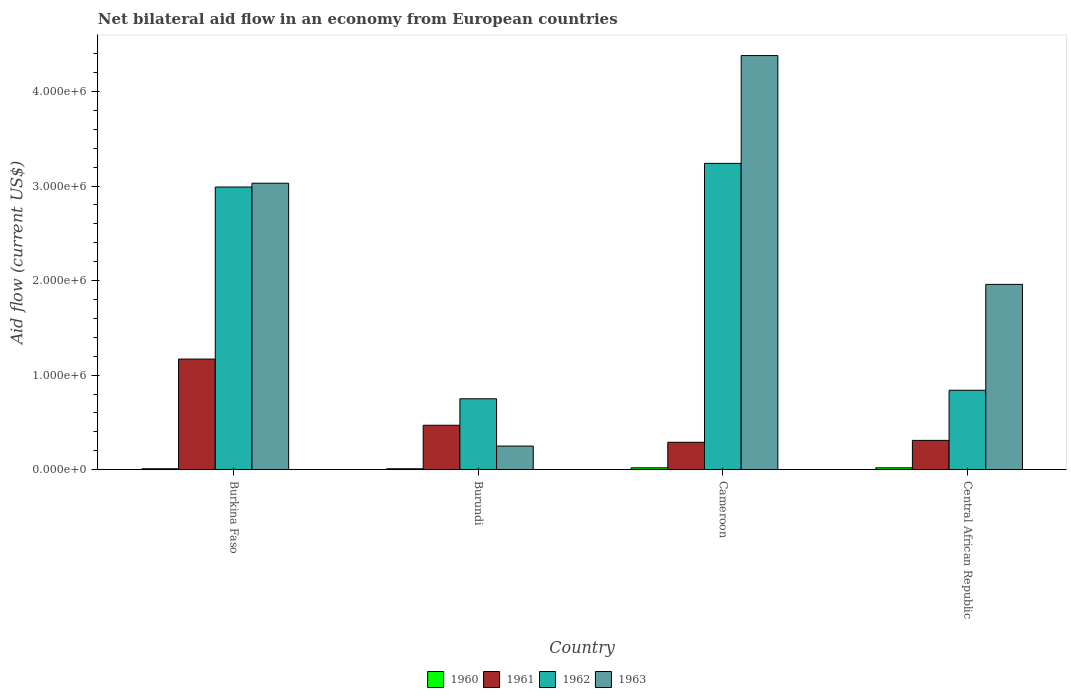How many groups of bars are there?
Give a very brief answer. 4. Are the number of bars per tick equal to the number of legend labels?
Make the answer very short. Yes. How many bars are there on the 4th tick from the left?
Provide a short and direct response. 4. How many bars are there on the 2nd tick from the right?
Provide a succinct answer. 4. What is the label of the 4th group of bars from the left?
Your response must be concise. Central African Republic. What is the net bilateral aid flow in 1962 in Central African Republic?
Offer a very short reply. 8.40e+05. Across all countries, what is the maximum net bilateral aid flow in 1963?
Offer a terse response. 4.38e+06. In which country was the net bilateral aid flow in 1960 maximum?
Offer a terse response. Cameroon. In which country was the net bilateral aid flow in 1960 minimum?
Provide a succinct answer. Burkina Faso. What is the total net bilateral aid flow in 1962 in the graph?
Provide a short and direct response. 7.82e+06. What is the difference between the net bilateral aid flow in 1963 in Burkina Faso and that in Central African Republic?
Make the answer very short. 1.07e+06. What is the difference between the net bilateral aid flow in 1961 in Central African Republic and the net bilateral aid flow in 1962 in Burkina Faso?
Your answer should be compact. -2.68e+06. What is the average net bilateral aid flow in 1961 per country?
Your answer should be very brief. 5.60e+05. What is the difference between the net bilateral aid flow of/in 1963 and net bilateral aid flow of/in 1962 in Central African Republic?
Provide a succinct answer. 1.12e+06. What is the ratio of the net bilateral aid flow in 1962 in Burkina Faso to that in Central African Republic?
Make the answer very short. 3.56. Is the net bilateral aid flow in 1960 in Cameroon less than that in Central African Republic?
Give a very brief answer. No. What is the difference between the highest and the lowest net bilateral aid flow in 1961?
Keep it short and to the point. 8.80e+05. Is it the case that in every country, the sum of the net bilateral aid flow in 1960 and net bilateral aid flow in 1963 is greater than the sum of net bilateral aid flow in 1962 and net bilateral aid flow in 1961?
Your answer should be compact. No. How many bars are there?
Give a very brief answer. 16. Are all the bars in the graph horizontal?
Keep it short and to the point. No. What is the difference between two consecutive major ticks on the Y-axis?
Keep it short and to the point. 1.00e+06. Are the values on the major ticks of Y-axis written in scientific E-notation?
Your answer should be compact. Yes. What is the title of the graph?
Give a very brief answer. Net bilateral aid flow in an economy from European countries. Does "1965" appear as one of the legend labels in the graph?
Offer a very short reply. No. What is the label or title of the X-axis?
Keep it short and to the point. Country. What is the label or title of the Y-axis?
Offer a very short reply. Aid flow (current US$). What is the Aid flow (current US$) of 1960 in Burkina Faso?
Offer a terse response. 10000. What is the Aid flow (current US$) of 1961 in Burkina Faso?
Offer a very short reply. 1.17e+06. What is the Aid flow (current US$) in 1962 in Burkina Faso?
Offer a very short reply. 2.99e+06. What is the Aid flow (current US$) in 1963 in Burkina Faso?
Your answer should be very brief. 3.03e+06. What is the Aid flow (current US$) in 1962 in Burundi?
Your answer should be very brief. 7.50e+05. What is the Aid flow (current US$) in 1960 in Cameroon?
Keep it short and to the point. 2.00e+04. What is the Aid flow (current US$) of 1961 in Cameroon?
Give a very brief answer. 2.90e+05. What is the Aid flow (current US$) in 1962 in Cameroon?
Your answer should be compact. 3.24e+06. What is the Aid flow (current US$) of 1963 in Cameroon?
Ensure brevity in your answer.  4.38e+06. What is the Aid flow (current US$) in 1961 in Central African Republic?
Ensure brevity in your answer.  3.10e+05. What is the Aid flow (current US$) of 1962 in Central African Republic?
Your answer should be very brief. 8.40e+05. What is the Aid flow (current US$) in 1963 in Central African Republic?
Give a very brief answer. 1.96e+06. Across all countries, what is the maximum Aid flow (current US$) in 1960?
Offer a terse response. 2.00e+04. Across all countries, what is the maximum Aid flow (current US$) in 1961?
Make the answer very short. 1.17e+06. Across all countries, what is the maximum Aid flow (current US$) in 1962?
Offer a terse response. 3.24e+06. Across all countries, what is the maximum Aid flow (current US$) in 1963?
Offer a terse response. 4.38e+06. Across all countries, what is the minimum Aid flow (current US$) of 1960?
Your answer should be compact. 10000. Across all countries, what is the minimum Aid flow (current US$) of 1962?
Provide a succinct answer. 7.50e+05. Across all countries, what is the minimum Aid flow (current US$) of 1963?
Your answer should be very brief. 2.50e+05. What is the total Aid flow (current US$) in 1960 in the graph?
Ensure brevity in your answer.  6.00e+04. What is the total Aid flow (current US$) of 1961 in the graph?
Make the answer very short. 2.24e+06. What is the total Aid flow (current US$) of 1962 in the graph?
Ensure brevity in your answer.  7.82e+06. What is the total Aid flow (current US$) of 1963 in the graph?
Your answer should be compact. 9.62e+06. What is the difference between the Aid flow (current US$) of 1960 in Burkina Faso and that in Burundi?
Your response must be concise. 0. What is the difference between the Aid flow (current US$) of 1962 in Burkina Faso and that in Burundi?
Offer a terse response. 2.24e+06. What is the difference between the Aid flow (current US$) of 1963 in Burkina Faso and that in Burundi?
Your response must be concise. 2.78e+06. What is the difference between the Aid flow (current US$) in 1961 in Burkina Faso and that in Cameroon?
Make the answer very short. 8.80e+05. What is the difference between the Aid flow (current US$) of 1962 in Burkina Faso and that in Cameroon?
Make the answer very short. -2.50e+05. What is the difference between the Aid flow (current US$) in 1963 in Burkina Faso and that in Cameroon?
Make the answer very short. -1.35e+06. What is the difference between the Aid flow (current US$) in 1960 in Burkina Faso and that in Central African Republic?
Ensure brevity in your answer.  -10000. What is the difference between the Aid flow (current US$) of 1961 in Burkina Faso and that in Central African Republic?
Your response must be concise. 8.60e+05. What is the difference between the Aid flow (current US$) of 1962 in Burkina Faso and that in Central African Republic?
Offer a very short reply. 2.15e+06. What is the difference between the Aid flow (current US$) in 1963 in Burkina Faso and that in Central African Republic?
Give a very brief answer. 1.07e+06. What is the difference between the Aid flow (current US$) in 1960 in Burundi and that in Cameroon?
Your answer should be very brief. -10000. What is the difference between the Aid flow (current US$) of 1961 in Burundi and that in Cameroon?
Offer a terse response. 1.80e+05. What is the difference between the Aid flow (current US$) in 1962 in Burundi and that in Cameroon?
Your answer should be very brief. -2.49e+06. What is the difference between the Aid flow (current US$) in 1963 in Burundi and that in Cameroon?
Keep it short and to the point. -4.13e+06. What is the difference between the Aid flow (current US$) of 1960 in Burundi and that in Central African Republic?
Your answer should be very brief. -10000. What is the difference between the Aid flow (current US$) of 1962 in Burundi and that in Central African Republic?
Keep it short and to the point. -9.00e+04. What is the difference between the Aid flow (current US$) in 1963 in Burundi and that in Central African Republic?
Make the answer very short. -1.71e+06. What is the difference between the Aid flow (current US$) of 1960 in Cameroon and that in Central African Republic?
Offer a very short reply. 0. What is the difference between the Aid flow (current US$) in 1962 in Cameroon and that in Central African Republic?
Give a very brief answer. 2.40e+06. What is the difference between the Aid flow (current US$) of 1963 in Cameroon and that in Central African Republic?
Offer a terse response. 2.42e+06. What is the difference between the Aid flow (current US$) in 1960 in Burkina Faso and the Aid flow (current US$) in 1961 in Burundi?
Provide a succinct answer. -4.60e+05. What is the difference between the Aid flow (current US$) in 1960 in Burkina Faso and the Aid flow (current US$) in 1962 in Burundi?
Provide a succinct answer. -7.40e+05. What is the difference between the Aid flow (current US$) in 1960 in Burkina Faso and the Aid flow (current US$) in 1963 in Burundi?
Provide a short and direct response. -2.40e+05. What is the difference between the Aid flow (current US$) of 1961 in Burkina Faso and the Aid flow (current US$) of 1963 in Burundi?
Give a very brief answer. 9.20e+05. What is the difference between the Aid flow (current US$) in 1962 in Burkina Faso and the Aid flow (current US$) in 1963 in Burundi?
Make the answer very short. 2.74e+06. What is the difference between the Aid flow (current US$) of 1960 in Burkina Faso and the Aid flow (current US$) of 1961 in Cameroon?
Make the answer very short. -2.80e+05. What is the difference between the Aid flow (current US$) in 1960 in Burkina Faso and the Aid flow (current US$) in 1962 in Cameroon?
Your response must be concise. -3.23e+06. What is the difference between the Aid flow (current US$) of 1960 in Burkina Faso and the Aid flow (current US$) of 1963 in Cameroon?
Provide a short and direct response. -4.37e+06. What is the difference between the Aid flow (current US$) of 1961 in Burkina Faso and the Aid flow (current US$) of 1962 in Cameroon?
Offer a very short reply. -2.07e+06. What is the difference between the Aid flow (current US$) in 1961 in Burkina Faso and the Aid flow (current US$) in 1963 in Cameroon?
Offer a very short reply. -3.21e+06. What is the difference between the Aid flow (current US$) in 1962 in Burkina Faso and the Aid flow (current US$) in 1963 in Cameroon?
Offer a very short reply. -1.39e+06. What is the difference between the Aid flow (current US$) of 1960 in Burkina Faso and the Aid flow (current US$) of 1962 in Central African Republic?
Offer a very short reply. -8.30e+05. What is the difference between the Aid flow (current US$) of 1960 in Burkina Faso and the Aid flow (current US$) of 1963 in Central African Republic?
Provide a succinct answer. -1.95e+06. What is the difference between the Aid flow (current US$) in 1961 in Burkina Faso and the Aid flow (current US$) in 1962 in Central African Republic?
Offer a very short reply. 3.30e+05. What is the difference between the Aid flow (current US$) in 1961 in Burkina Faso and the Aid flow (current US$) in 1963 in Central African Republic?
Offer a terse response. -7.90e+05. What is the difference between the Aid flow (current US$) of 1962 in Burkina Faso and the Aid flow (current US$) of 1963 in Central African Republic?
Your answer should be compact. 1.03e+06. What is the difference between the Aid flow (current US$) of 1960 in Burundi and the Aid flow (current US$) of 1961 in Cameroon?
Provide a succinct answer. -2.80e+05. What is the difference between the Aid flow (current US$) in 1960 in Burundi and the Aid flow (current US$) in 1962 in Cameroon?
Keep it short and to the point. -3.23e+06. What is the difference between the Aid flow (current US$) in 1960 in Burundi and the Aid flow (current US$) in 1963 in Cameroon?
Provide a succinct answer. -4.37e+06. What is the difference between the Aid flow (current US$) in 1961 in Burundi and the Aid flow (current US$) in 1962 in Cameroon?
Your answer should be compact. -2.77e+06. What is the difference between the Aid flow (current US$) in 1961 in Burundi and the Aid flow (current US$) in 1963 in Cameroon?
Offer a very short reply. -3.91e+06. What is the difference between the Aid flow (current US$) in 1962 in Burundi and the Aid flow (current US$) in 1963 in Cameroon?
Make the answer very short. -3.63e+06. What is the difference between the Aid flow (current US$) of 1960 in Burundi and the Aid flow (current US$) of 1962 in Central African Republic?
Offer a very short reply. -8.30e+05. What is the difference between the Aid flow (current US$) of 1960 in Burundi and the Aid flow (current US$) of 1963 in Central African Republic?
Provide a short and direct response. -1.95e+06. What is the difference between the Aid flow (current US$) in 1961 in Burundi and the Aid flow (current US$) in 1962 in Central African Republic?
Keep it short and to the point. -3.70e+05. What is the difference between the Aid flow (current US$) of 1961 in Burundi and the Aid flow (current US$) of 1963 in Central African Republic?
Offer a very short reply. -1.49e+06. What is the difference between the Aid flow (current US$) of 1962 in Burundi and the Aid flow (current US$) of 1963 in Central African Republic?
Make the answer very short. -1.21e+06. What is the difference between the Aid flow (current US$) in 1960 in Cameroon and the Aid flow (current US$) in 1961 in Central African Republic?
Your answer should be very brief. -2.90e+05. What is the difference between the Aid flow (current US$) of 1960 in Cameroon and the Aid flow (current US$) of 1962 in Central African Republic?
Keep it short and to the point. -8.20e+05. What is the difference between the Aid flow (current US$) of 1960 in Cameroon and the Aid flow (current US$) of 1963 in Central African Republic?
Give a very brief answer. -1.94e+06. What is the difference between the Aid flow (current US$) of 1961 in Cameroon and the Aid flow (current US$) of 1962 in Central African Republic?
Make the answer very short. -5.50e+05. What is the difference between the Aid flow (current US$) of 1961 in Cameroon and the Aid flow (current US$) of 1963 in Central African Republic?
Offer a terse response. -1.67e+06. What is the difference between the Aid flow (current US$) in 1962 in Cameroon and the Aid flow (current US$) in 1963 in Central African Republic?
Provide a short and direct response. 1.28e+06. What is the average Aid flow (current US$) in 1960 per country?
Provide a succinct answer. 1.50e+04. What is the average Aid flow (current US$) of 1961 per country?
Provide a short and direct response. 5.60e+05. What is the average Aid flow (current US$) in 1962 per country?
Offer a terse response. 1.96e+06. What is the average Aid flow (current US$) in 1963 per country?
Your response must be concise. 2.40e+06. What is the difference between the Aid flow (current US$) of 1960 and Aid flow (current US$) of 1961 in Burkina Faso?
Your response must be concise. -1.16e+06. What is the difference between the Aid flow (current US$) of 1960 and Aid flow (current US$) of 1962 in Burkina Faso?
Your answer should be very brief. -2.98e+06. What is the difference between the Aid flow (current US$) in 1960 and Aid flow (current US$) in 1963 in Burkina Faso?
Keep it short and to the point. -3.02e+06. What is the difference between the Aid flow (current US$) of 1961 and Aid flow (current US$) of 1962 in Burkina Faso?
Ensure brevity in your answer.  -1.82e+06. What is the difference between the Aid flow (current US$) of 1961 and Aid flow (current US$) of 1963 in Burkina Faso?
Provide a short and direct response. -1.86e+06. What is the difference between the Aid flow (current US$) of 1962 and Aid flow (current US$) of 1963 in Burkina Faso?
Offer a terse response. -4.00e+04. What is the difference between the Aid flow (current US$) of 1960 and Aid flow (current US$) of 1961 in Burundi?
Make the answer very short. -4.60e+05. What is the difference between the Aid flow (current US$) in 1960 and Aid flow (current US$) in 1962 in Burundi?
Ensure brevity in your answer.  -7.40e+05. What is the difference between the Aid flow (current US$) of 1960 and Aid flow (current US$) of 1963 in Burundi?
Your answer should be very brief. -2.40e+05. What is the difference between the Aid flow (current US$) of 1961 and Aid flow (current US$) of 1962 in Burundi?
Your answer should be compact. -2.80e+05. What is the difference between the Aid flow (current US$) of 1961 and Aid flow (current US$) of 1963 in Burundi?
Provide a short and direct response. 2.20e+05. What is the difference between the Aid flow (current US$) of 1962 and Aid flow (current US$) of 1963 in Burundi?
Offer a very short reply. 5.00e+05. What is the difference between the Aid flow (current US$) in 1960 and Aid flow (current US$) in 1961 in Cameroon?
Offer a very short reply. -2.70e+05. What is the difference between the Aid flow (current US$) of 1960 and Aid flow (current US$) of 1962 in Cameroon?
Your answer should be very brief. -3.22e+06. What is the difference between the Aid flow (current US$) in 1960 and Aid flow (current US$) in 1963 in Cameroon?
Ensure brevity in your answer.  -4.36e+06. What is the difference between the Aid flow (current US$) of 1961 and Aid flow (current US$) of 1962 in Cameroon?
Offer a very short reply. -2.95e+06. What is the difference between the Aid flow (current US$) of 1961 and Aid flow (current US$) of 1963 in Cameroon?
Ensure brevity in your answer.  -4.09e+06. What is the difference between the Aid flow (current US$) in 1962 and Aid flow (current US$) in 1963 in Cameroon?
Make the answer very short. -1.14e+06. What is the difference between the Aid flow (current US$) in 1960 and Aid flow (current US$) in 1961 in Central African Republic?
Offer a very short reply. -2.90e+05. What is the difference between the Aid flow (current US$) of 1960 and Aid flow (current US$) of 1962 in Central African Republic?
Provide a short and direct response. -8.20e+05. What is the difference between the Aid flow (current US$) in 1960 and Aid flow (current US$) in 1963 in Central African Republic?
Offer a very short reply. -1.94e+06. What is the difference between the Aid flow (current US$) of 1961 and Aid flow (current US$) of 1962 in Central African Republic?
Offer a very short reply. -5.30e+05. What is the difference between the Aid flow (current US$) in 1961 and Aid flow (current US$) in 1963 in Central African Republic?
Provide a succinct answer. -1.65e+06. What is the difference between the Aid flow (current US$) of 1962 and Aid flow (current US$) of 1963 in Central African Republic?
Ensure brevity in your answer.  -1.12e+06. What is the ratio of the Aid flow (current US$) of 1960 in Burkina Faso to that in Burundi?
Offer a terse response. 1. What is the ratio of the Aid flow (current US$) in 1961 in Burkina Faso to that in Burundi?
Give a very brief answer. 2.49. What is the ratio of the Aid flow (current US$) in 1962 in Burkina Faso to that in Burundi?
Keep it short and to the point. 3.99. What is the ratio of the Aid flow (current US$) in 1963 in Burkina Faso to that in Burundi?
Offer a very short reply. 12.12. What is the ratio of the Aid flow (current US$) in 1960 in Burkina Faso to that in Cameroon?
Make the answer very short. 0.5. What is the ratio of the Aid flow (current US$) of 1961 in Burkina Faso to that in Cameroon?
Ensure brevity in your answer.  4.03. What is the ratio of the Aid flow (current US$) of 1962 in Burkina Faso to that in Cameroon?
Give a very brief answer. 0.92. What is the ratio of the Aid flow (current US$) in 1963 in Burkina Faso to that in Cameroon?
Provide a short and direct response. 0.69. What is the ratio of the Aid flow (current US$) of 1960 in Burkina Faso to that in Central African Republic?
Offer a terse response. 0.5. What is the ratio of the Aid flow (current US$) in 1961 in Burkina Faso to that in Central African Republic?
Your answer should be very brief. 3.77. What is the ratio of the Aid flow (current US$) in 1962 in Burkina Faso to that in Central African Republic?
Give a very brief answer. 3.56. What is the ratio of the Aid flow (current US$) in 1963 in Burkina Faso to that in Central African Republic?
Your answer should be compact. 1.55. What is the ratio of the Aid flow (current US$) in 1961 in Burundi to that in Cameroon?
Make the answer very short. 1.62. What is the ratio of the Aid flow (current US$) in 1962 in Burundi to that in Cameroon?
Provide a succinct answer. 0.23. What is the ratio of the Aid flow (current US$) in 1963 in Burundi to that in Cameroon?
Offer a terse response. 0.06. What is the ratio of the Aid flow (current US$) in 1960 in Burundi to that in Central African Republic?
Offer a very short reply. 0.5. What is the ratio of the Aid flow (current US$) in 1961 in Burundi to that in Central African Republic?
Offer a terse response. 1.52. What is the ratio of the Aid flow (current US$) in 1962 in Burundi to that in Central African Republic?
Your answer should be very brief. 0.89. What is the ratio of the Aid flow (current US$) in 1963 in Burundi to that in Central African Republic?
Provide a succinct answer. 0.13. What is the ratio of the Aid flow (current US$) in 1961 in Cameroon to that in Central African Republic?
Your answer should be compact. 0.94. What is the ratio of the Aid flow (current US$) of 1962 in Cameroon to that in Central African Republic?
Provide a succinct answer. 3.86. What is the ratio of the Aid flow (current US$) in 1963 in Cameroon to that in Central African Republic?
Offer a very short reply. 2.23. What is the difference between the highest and the second highest Aid flow (current US$) in 1960?
Make the answer very short. 0. What is the difference between the highest and the second highest Aid flow (current US$) in 1962?
Provide a short and direct response. 2.50e+05. What is the difference between the highest and the second highest Aid flow (current US$) of 1963?
Make the answer very short. 1.35e+06. What is the difference between the highest and the lowest Aid flow (current US$) in 1960?
Your answer should be very brief. 10000. What is the difference between the highest and the lowest Aid flow (current US$) in 1961?
Offer a very short reply. 8.80e+05. What is the difference between the highest and the lowest Aid flow (current US$) of 1962?
Your answer should be very brief. 2.49e+06. What is the difference between the highest and the lowest Aid flow (current US$) in 1963?
Make the answer very short. 4.13e+06. 